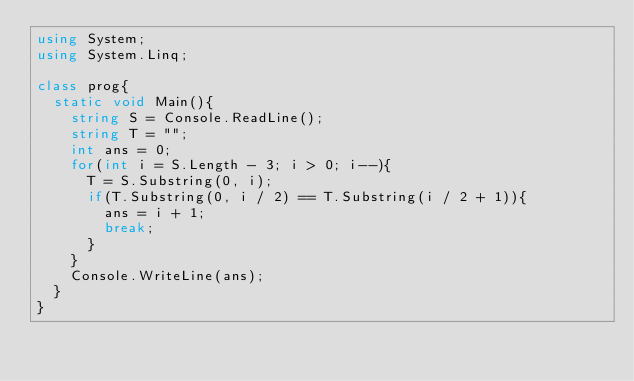Convert code to text. <code><loc_0><loc_0><loc_500><loc_500><_C#_>using System;
using System.Linq;

class prog{
  static void Main(){
    string S = Console.ReadLine();
    string T = "";
    int ans = 0;
    for(int i = S.Length - 3; i > 0; i--){
      T = S.Substring(0, i);
      if(T.Substring(0, i / 2) == T.Substring(i / 2 + 1)){
        ans = i + 1;
        break;
      }
    }
    Console.WriteLine(ans);
  }
}
    </code> 